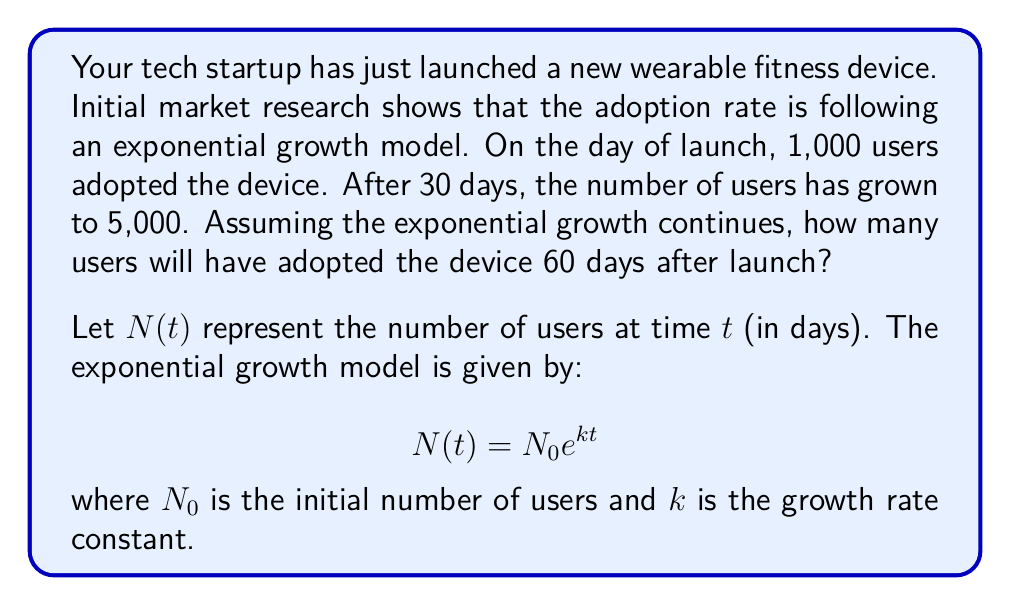Can you answer this question? To solve this problem, we'll follow these steps:

1) We know that $N_0 = 1,000$ (initial users on launch day)

2) We can set up an equation using the information at 30 days:
   $$5,000 = 1,000 e^{k(30)}$$

3) Solve for $k$:
   $$5 = e^{30k}$$
   $$\ln(5) = 30k$$
   $$k = \frac{\ln(5)}{30} \approx 0.0532$$

4) Now that we have $k$, we can use the exponential growth formula to find $N(60)$:
   $$N(60) = 1,000 e^{0.0532(60)}$$

5) Calculate the result:
   $$N(60) = 1,000 e^{3.192} \approx 24,532$$

Therefore, after 60 days, approximately 24,532 users will have adopted the device.
Answer: 24,532 users 